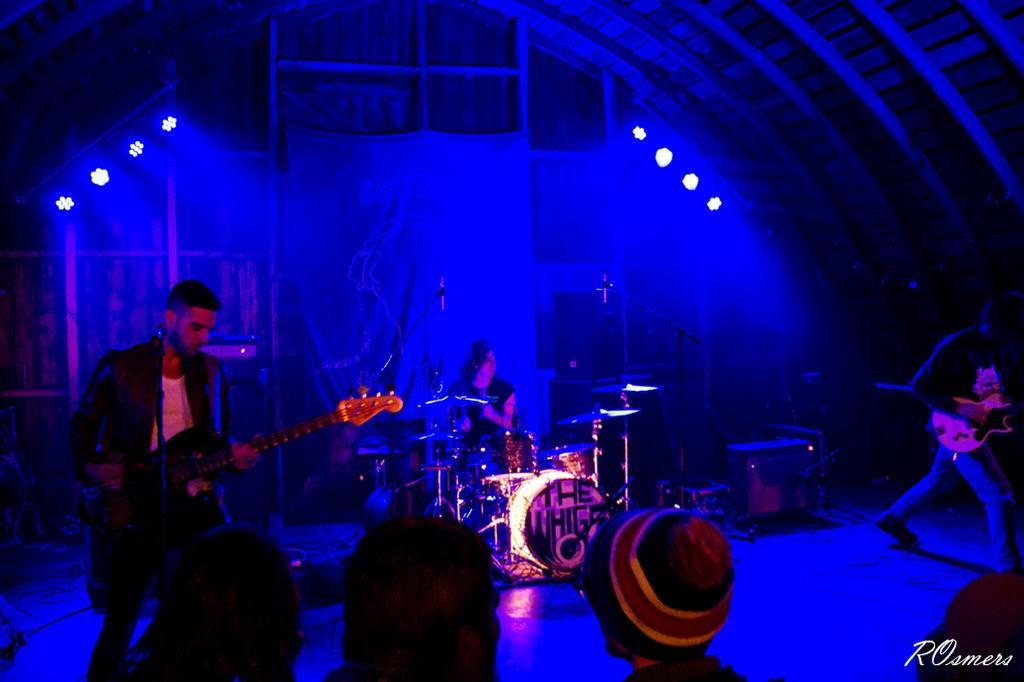Could you give a brief overview of what you see in this image? In this image on the left side there is one man who is standing and he is playing guitar, and on the right side there is another man who is standing and he is playing a guitar. And on the bottom there are some people and in the center there is one person who is sitting and playing drums and on the background there is a wooden wall and some lights are there. 